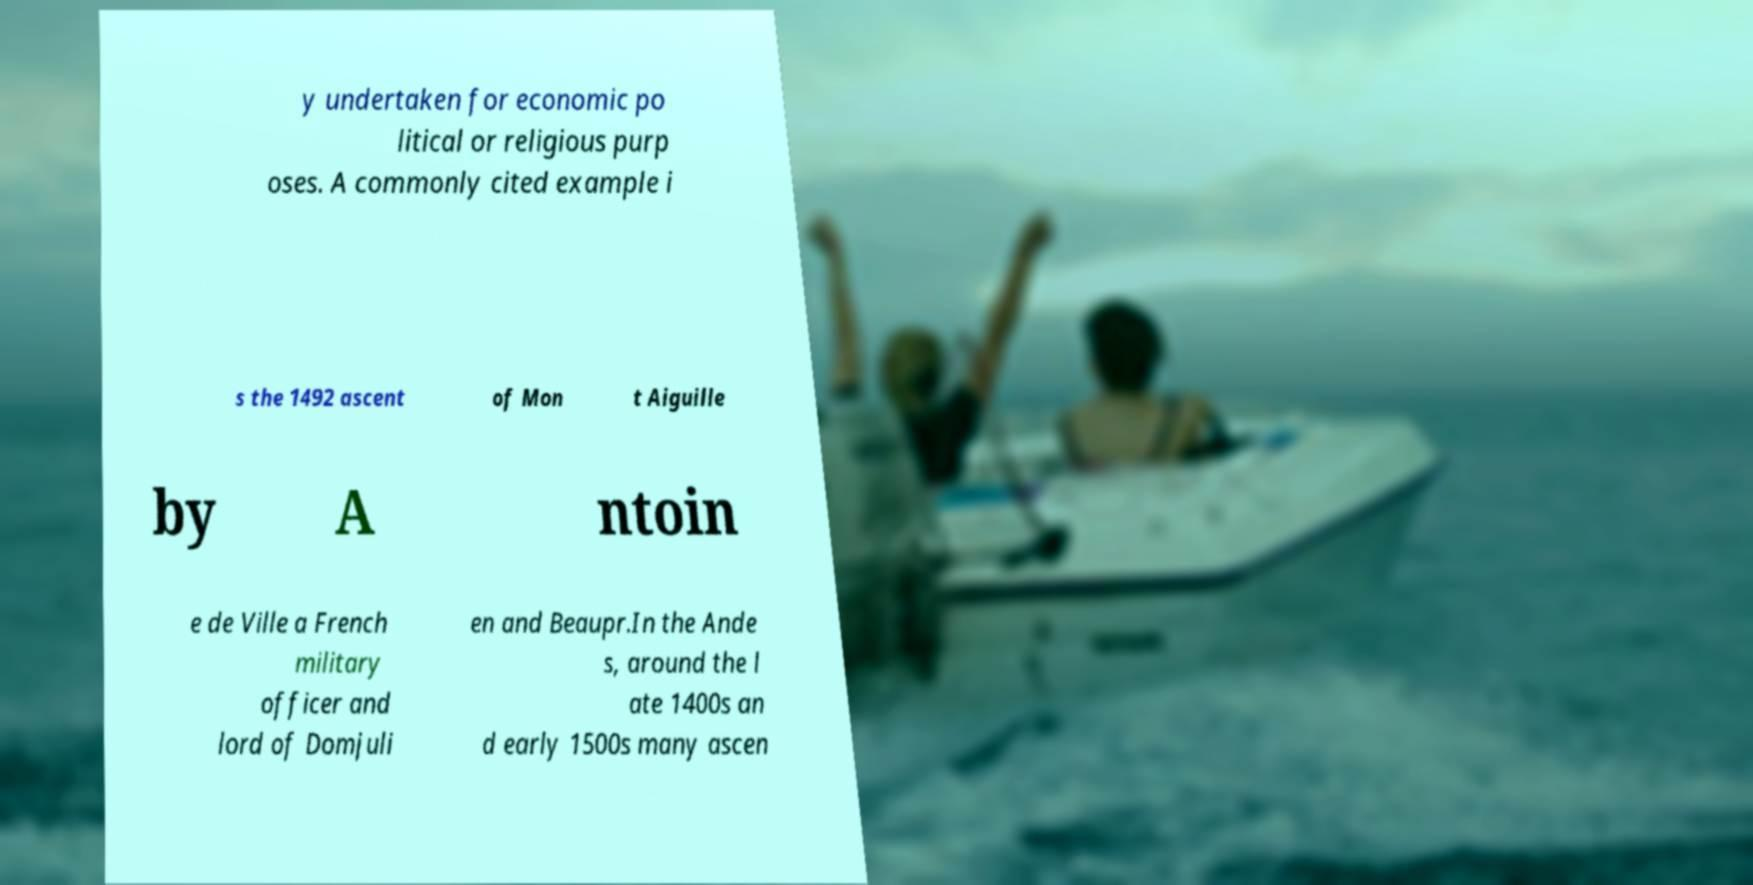Please identify and transcribe the text found in this image. y undertaken for economic po litical or religious purp oses. A commonly cited example i s the 1492 ascent of Mon t Aiguille by A ntoin e de Ville a French military officer and lord of Domjuli en and Beaupr.In the Ande s, around the l ate 1400s an d early 1500s many ascen 